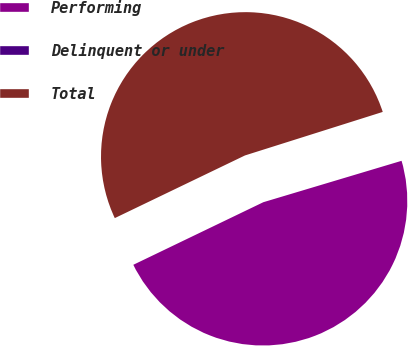Convert chart. <chart><loc_0><loc_0><loc_500><loc_500><pie_chart><fcel>Performing<fcel>Delinquent or under<fcel>Total<nl><fcel>47.49%<fcel>0.24%<fcel>52.27%<nl></chart> 